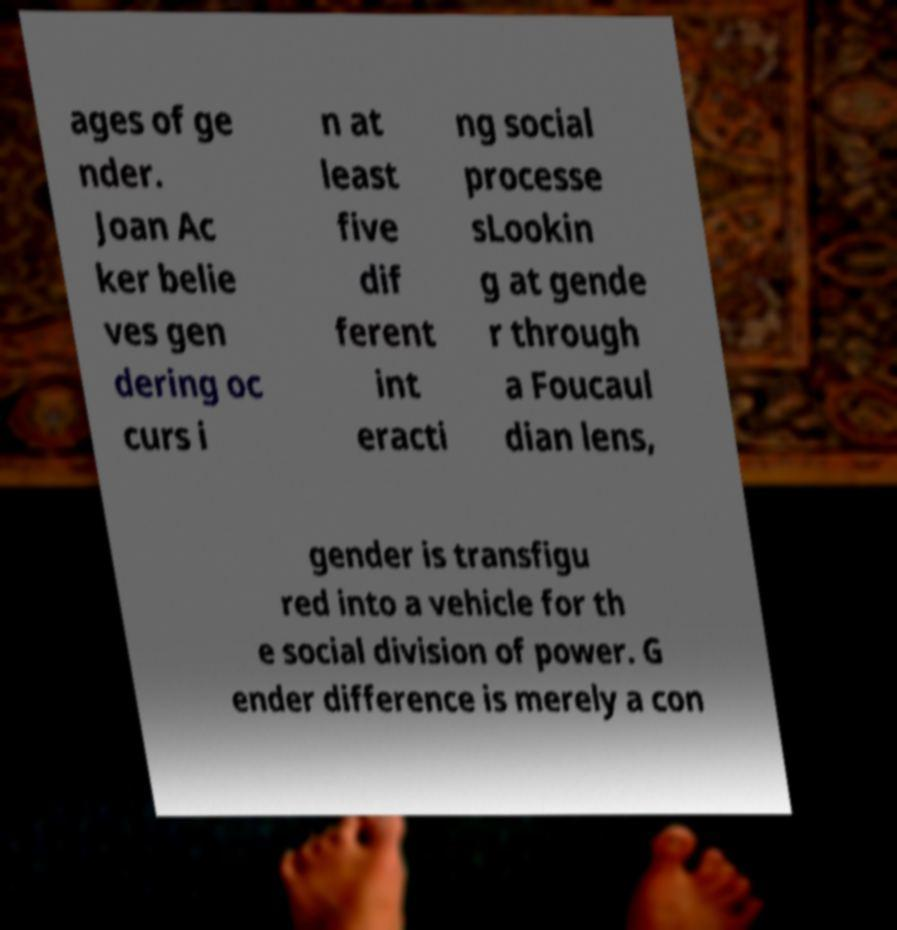For documentation purposes, I need the text within this image transcribed. Could you provide that? ages of ge nder. Joan Ac ker belie ves gen dering oc curs i n at least five dif ferent int eracti ng social processe sLookin g at gende r through a Foucaul dian lens, gender is transfigu red into a vehicle for th e social division of power. G ender difference is merely a con 